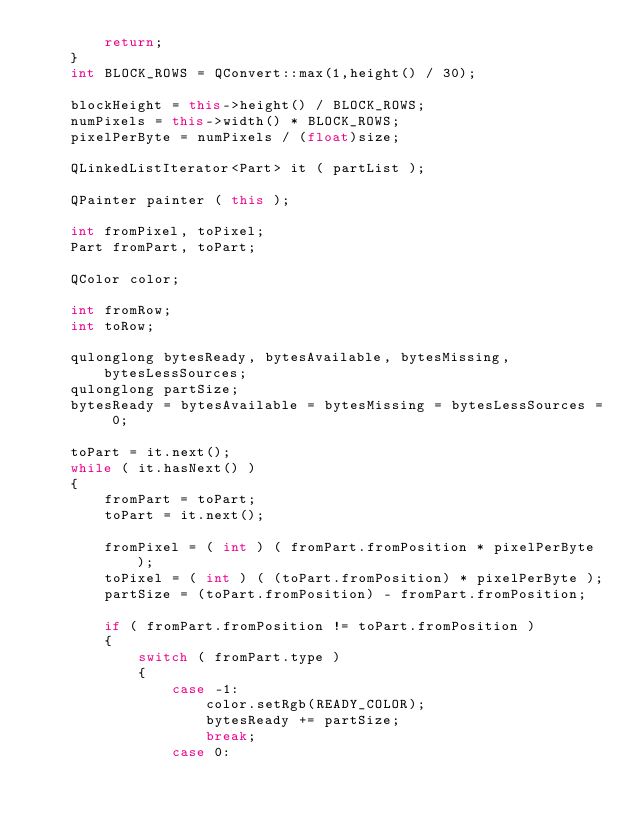Convert code to text. <code><loc_0><loc_0><loc_500><loc_500><_C++_>        return;
    }
    int BLOCK_ROWS = QConvert::max(1,height() / 30);

    blockHeight = this->height() / BLOCK_ROWS;
    numPixels = this->width() * BLOCK_ROWS;
    pixelPerByte = numPixels / (float)size;
    
    QLinkedListIterator<Part> it ( partList );
    
    QPainter painter ( this );
    
    int fromPixel, toPixel;
    Part fromPart, toPart;
    
    QColor color;
    
    int fromRow;
    int toRow;
    
    qulonglong bytesReady, bytesAvailable, bytesMissing, bytesLessSources;
    qulonglong partSize;
    bytesReady = bytesAvailable = bytesMissing = bytesLessSources = 0;

    toPart = it.next();
    while ( it.hasNext() )
    {
        fromPart = toPart;
        toPart = it.next();

        fromPixel = ( int ) ( fromPart.fromPosition * pixelPerByte );
        toPixel = ( int ) ( (toPart.fromPosition) * pixelPerByte );
        partSize = (toPart.fromPosition) - fromPart.fromPosition;
    
        if ( fromPart.fromPosition != toPart.fromPosition )
        {
            switch ( fromPart.type )
            {
                case -1:
                    color.setRgb(READY_COLOR);
                    bytesReady += partSize;
                    break;
                case 0:</code> 